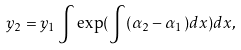Convert formula to latex. <formula><loc_0><loc_0><loc_500><loc_500>y _ { 2 } = y _ { 1 } \int \exp ( \int ( \alpha _ { 2 } - \alpha _ { 1 } ) d x ) d x ,</formula> 